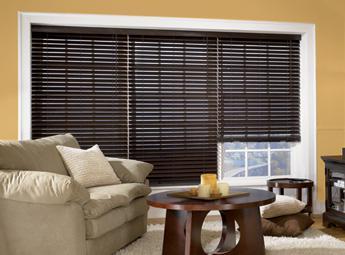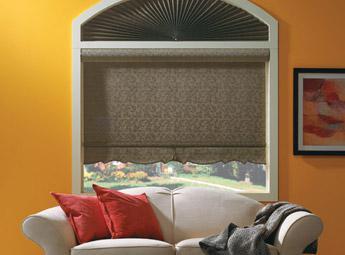The first image is the image on the left, the second image is the image on the right. Analyze the images presented: Is the assertion "The left and right image contains the a total of four window." valid? Answer yes or no. Yes. 